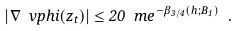<formula> <loc_0><loc_0><loc_500><loc_500>| \nabla \ v p h i ( z _ { t } ) | \leq 2 0 \ m e ^ { - \beta _ { 3 / 4 } ( h ; B _ { 1 } ) } \ .</formula> 